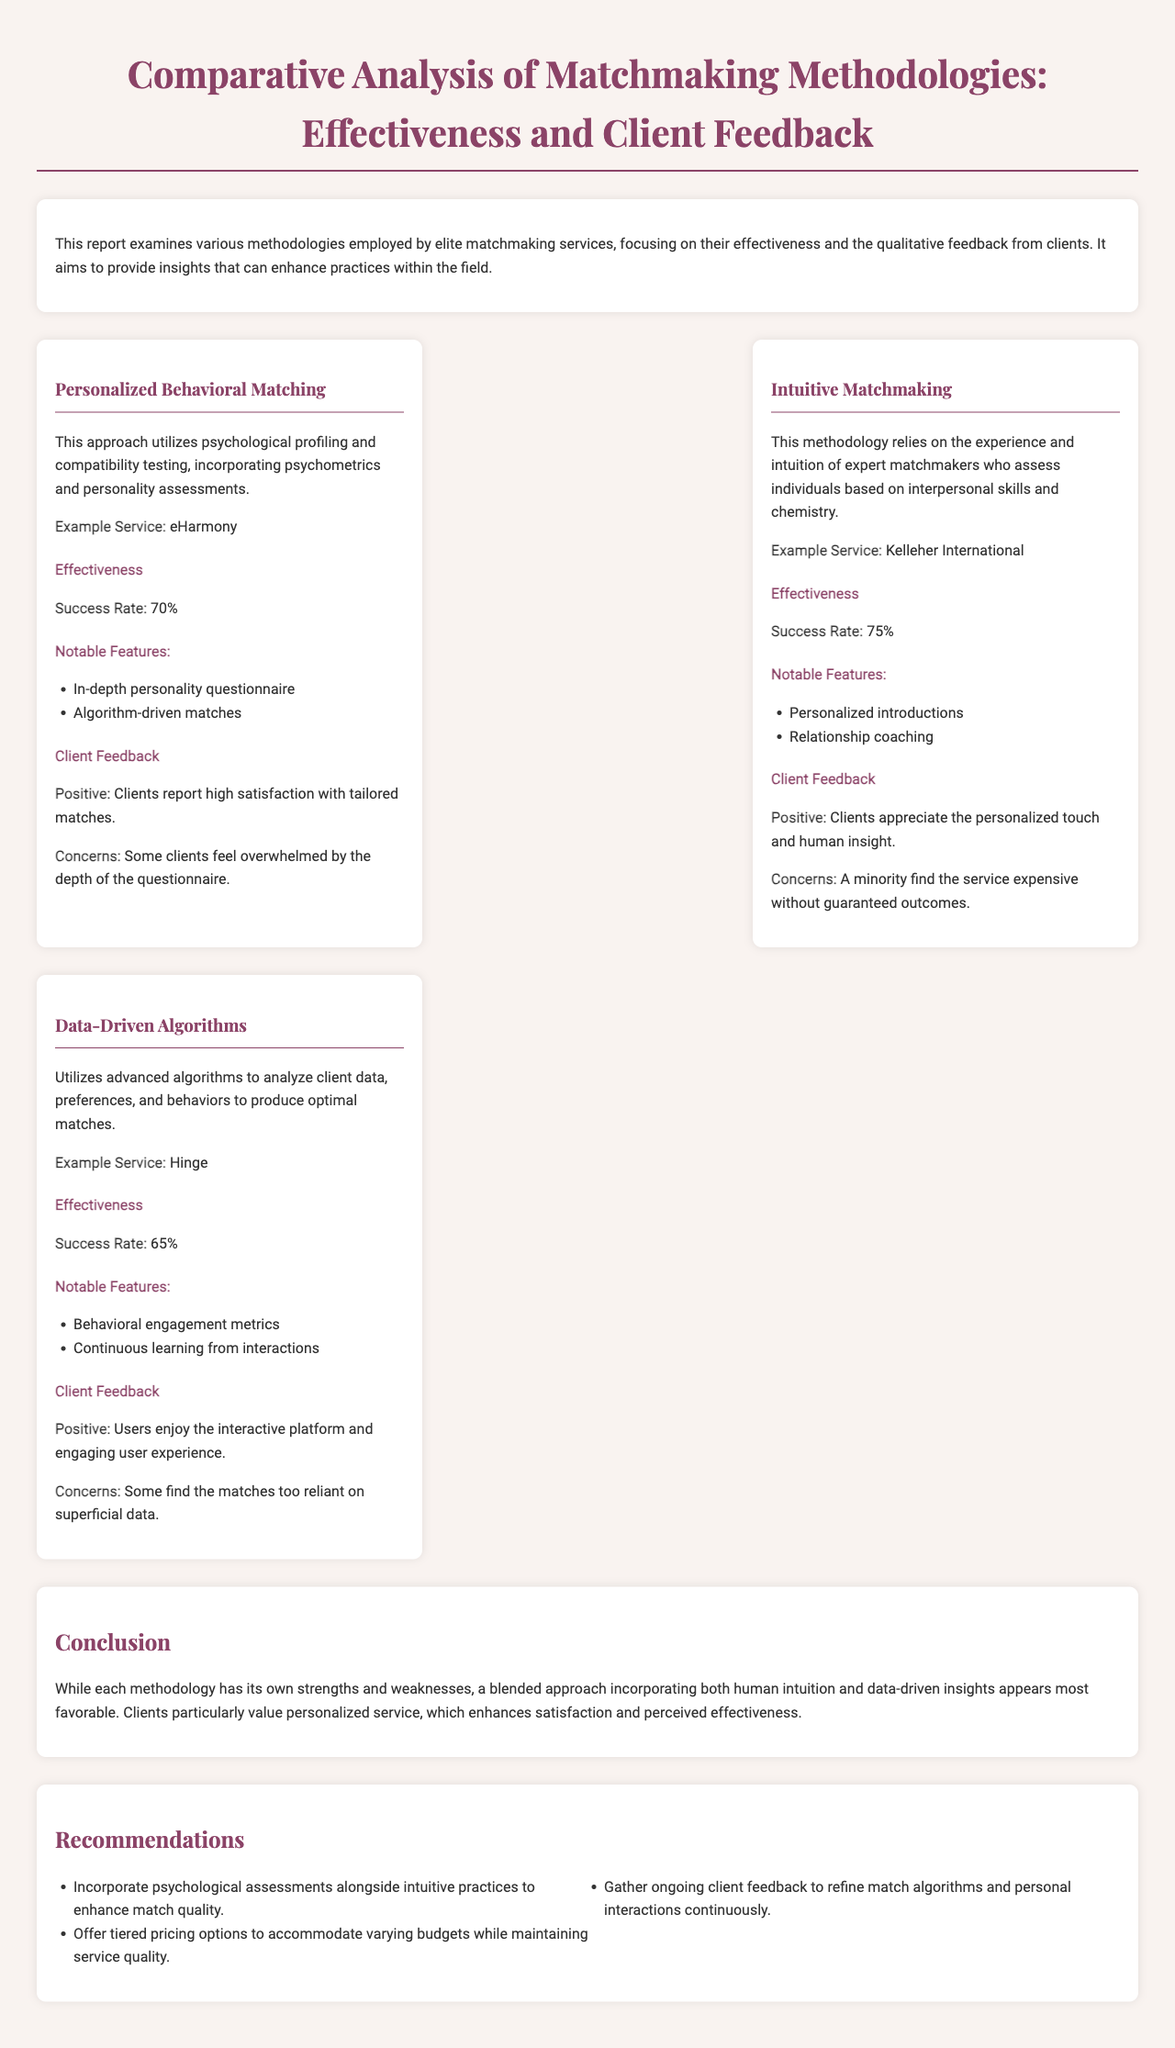What is the success rate of Personalized Behavioral Matching? The success rate for Personalized Behavioral Matching, as stated in the document, is noted to be 70%.
Answer: 70% What is an example service for Intuitive Matchmaking? The document provides Kelleher International as an example service for Intuitive Matchmaking.
Answer: Kelleher International What notable feature is listed for Data-Driven Algorithms? The notable features include "Behavioral engagement metrics" as mentioned in the Data-Driven Algorithms section of the document.
Answer: Behavioral engagement metrics What is the overall conclusion about matchmaking methodologies? The document concludes that a blended approach that incorporates both human intuition and data-driven insights appears most favorable.
Answer: A blended approach What recommendation is made regarding client feedback? The document suggests gathering ongoing client feedback to refine match algorithms and personal interactions continuously as one of its recommendations.
Answer: Ongoing client feedback 